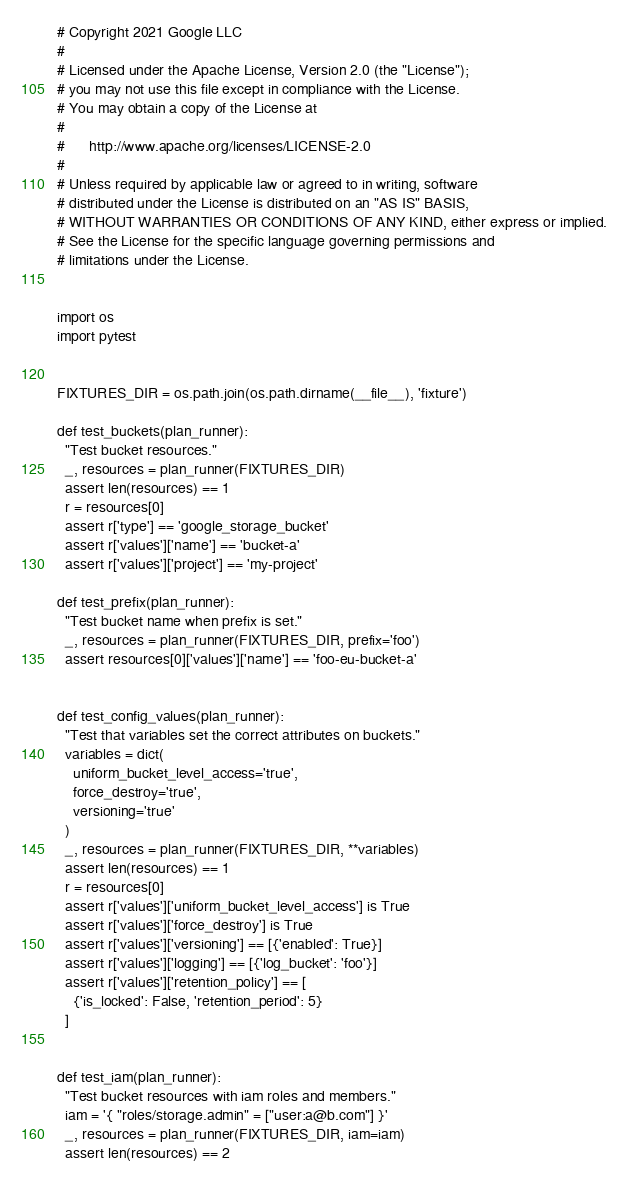Convert code to text. <code><loc_0><loc_0><loc_500><loc_500><_Python_># Copyright 2021 Google LLC
#
# Licensed under the Apache License, Version 2.0 (the "License");
# you may not use this file except in compliance with the License.
# You may obtain a copy of the License at
#
#      http://www.apache.org/licenses/LICENSE-2.0
#
# Unless required by applicable law or agreed to in writing, software
# distributed under the License is distributed on an "AS IS" BASIS,
# WITHOUT WARRANTIES OR CONDITIONS OF ANY KIND, either express or implied.
# See the License for the specific language governing permissions and
# limitations under the License.


import os
import pytest


FIXTURES_DIR = os.path.join(os.path.dirname(__file__), 'fixture')

def test_buckets(plan_runner):
  "Test bucket resources."
  _, resources = plan_runner(FIXTURES_DIR)
  assert len(resources) == 1
  r = resources[0]
  assert r['type'] == 'google_storage_bucket'
  assert r['values']['name'] == 'bucket-a'
  assert r['values']['project'] == 'my-project'

def test_prefix(plan_runner):
  "Test bucket name when prefix is set."
  _, resources = plan_runner(FIXTURES_DIR, prefix='foo')
  assert resources[0]['values']['name'] == 'foo-eu-bucket-a'


def test_config_values(plan_runner):
  "Test that variables set the correct attributes on buckets."
  variables = dict(
    uniform_bucket_level_access='true',
    force_destroy='true',
    versioning='true'
  )
  _, resources = plan_runner(FIXTURES_DIR, **variables)
  assert len(resources) == 1
  r = resources[0]
  assert r['values']['uniform_bucket_level_access'] is True
  assert r['values']['force_destroy'] is True
  assert r['values']['versioning'] == [{'enabled': True}]
  assert r['values']['logging'] == [{'log_bucket': 'foo'}]
  assert r['values']['retention_policy'] == [
    {'is_locked': False, 'retention_period': 5}
  ]


def test_iam(plan_runner):
  "Test bucket resources with iam roles and members."
  iam = '{ "roles/storage.admin" = ["user:a@b.com"] }'
  _, resources = plan_runner(FIXTURES_DIR, iam=iam)
  assert len(resources) == 2
</code> 